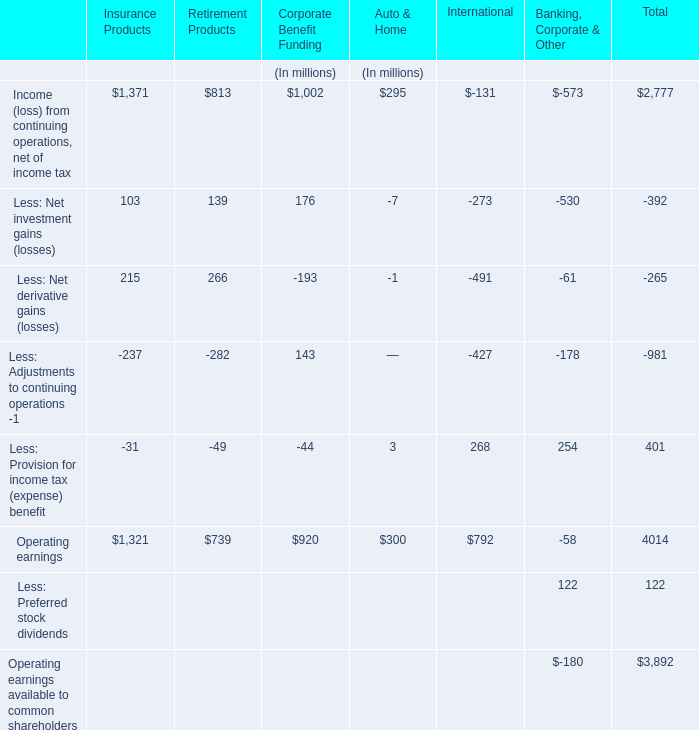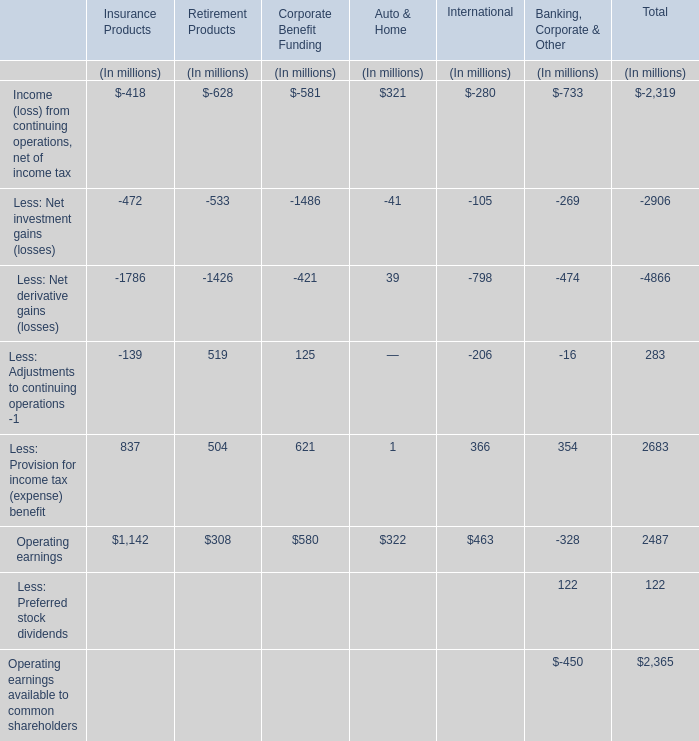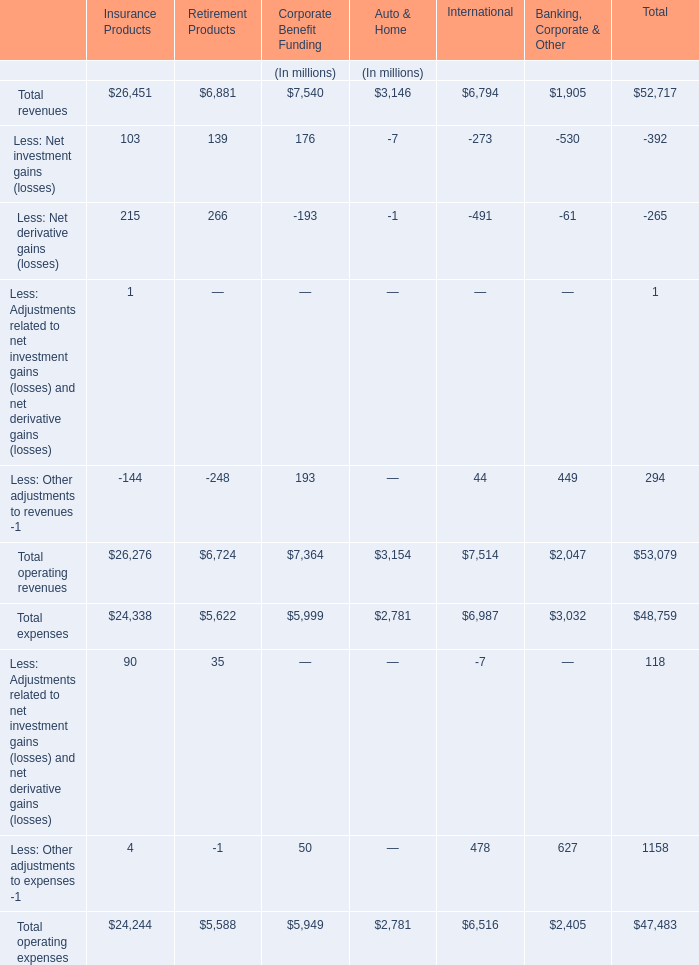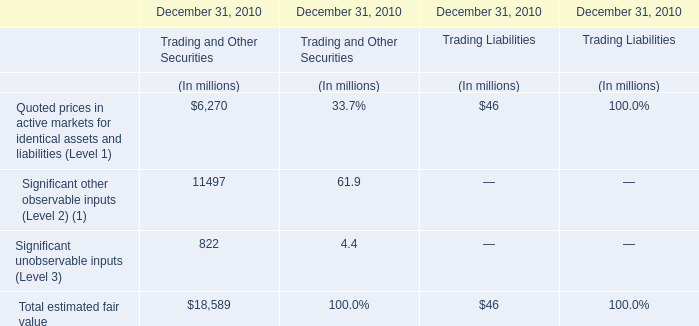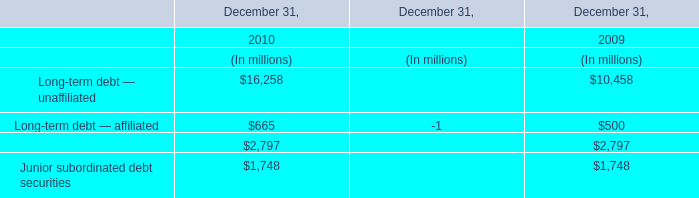What's the sum of all operating revenues that are greater than -200 in International? (in million) 
Computations: (6794 + 44)
Answer: 6838.0. 